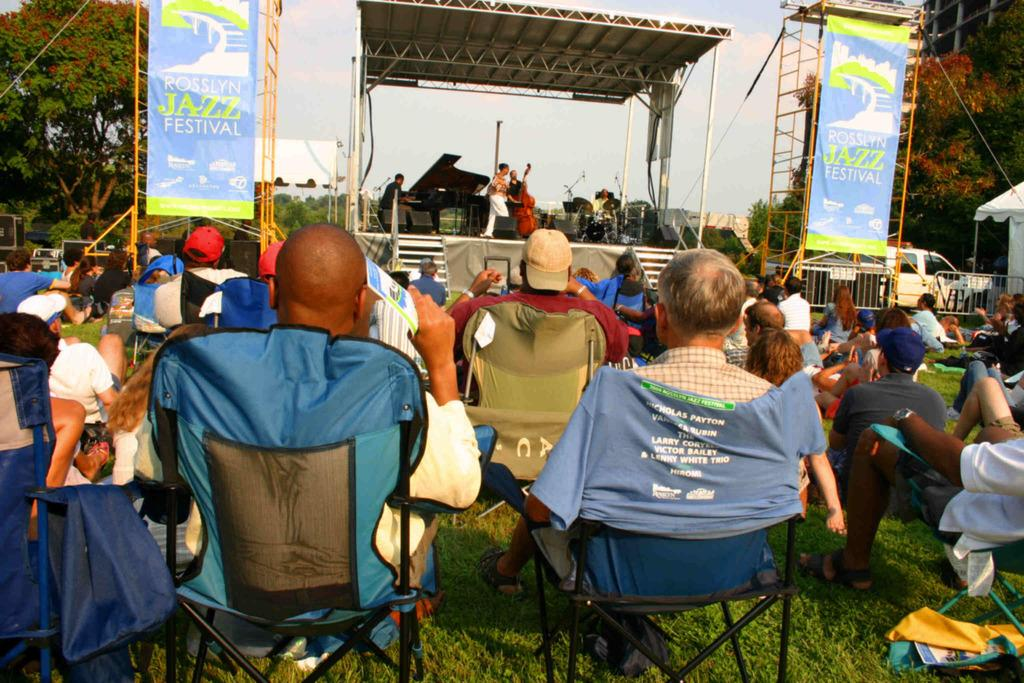What are the people in the foreground of the image doing? The people in the foreground of the image are sitting on chairs in the grassland. What activity is taking place in the background of the image? People are playing music instruments on a stage in the background. What can be seen in the sky in the image? The sky is visible in the image. What type of leather is being used to make the stew in the image? There is no mention of leather or stew in the image; it features people sitting on chairs in the grassland and others playing music instruments on a stage in the background. 